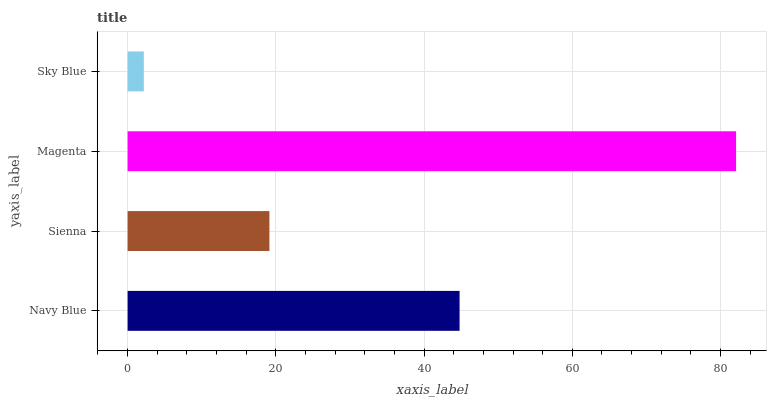Is Sky Blue the minimum?
Answer yes or no. Yes. Is Magenta the maximum?
Answer yes or no. Yes. Is Sienna the minimum?
Answer yes or no. No. Is Sienna the maximum?
Answer yes or no. No. Is Navy Blue greater than Sienna?
Answer yes or no. Yes. Is Sienna less than Navy Blue?
Answer yes or no. Yes. Is Sienna greater than Navy Blue?
Answer yes or no. No. Is Navy Blue less than Sienna?
Answer yes or no. No. Is Navy Blue the high median?
Answer yes or no. Yes. Is Sienna the low median?
Answer yes or no. Yes. Is Sienna the high median?
Answer yes or no. No. Is Sky Blue the low median?
Answer yes or no. No. 